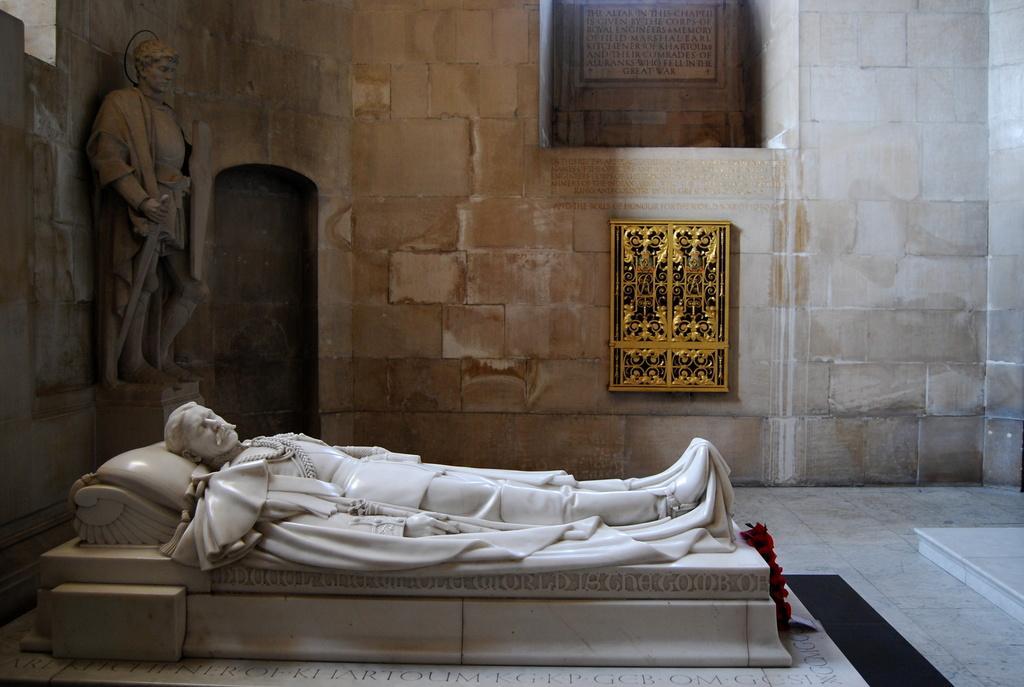In one or two sentences, can you explain what this image depicts? In this image I can see a person's status is lying on the bed in a hall. In the background I can see a person's sculpture, wall painting, board and a wall. This image is taken may be in a museum. 